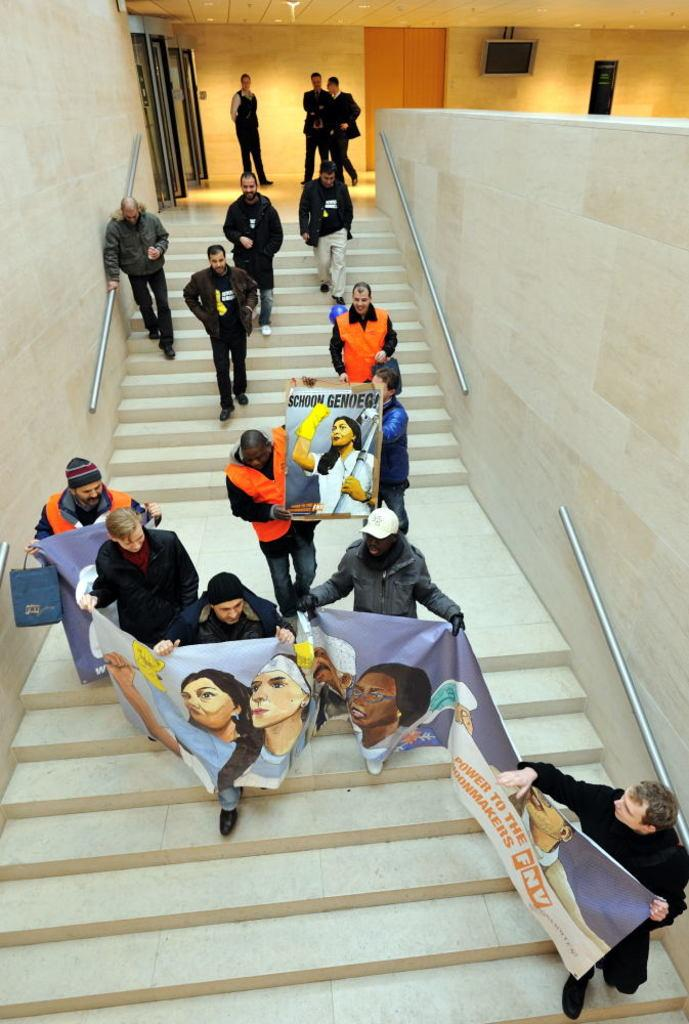What is happening with the people in the image? The people in the image are getting down the stairs. What are the people holding in the image? The people are holding a placard and a banner. What can be seen in the background of the image? There is a building in the image. Are there any other people in the image besides those getting down the stairs? Yes, there are people standing in the image. What is the acoustics like in the image? The provided facts do not mention anything about the acoustics in the image, so it cannot be determined. How does the brother feel about the situation in the image? There is no mention of a brother or any emotions in the image, so it cannot be determined. 